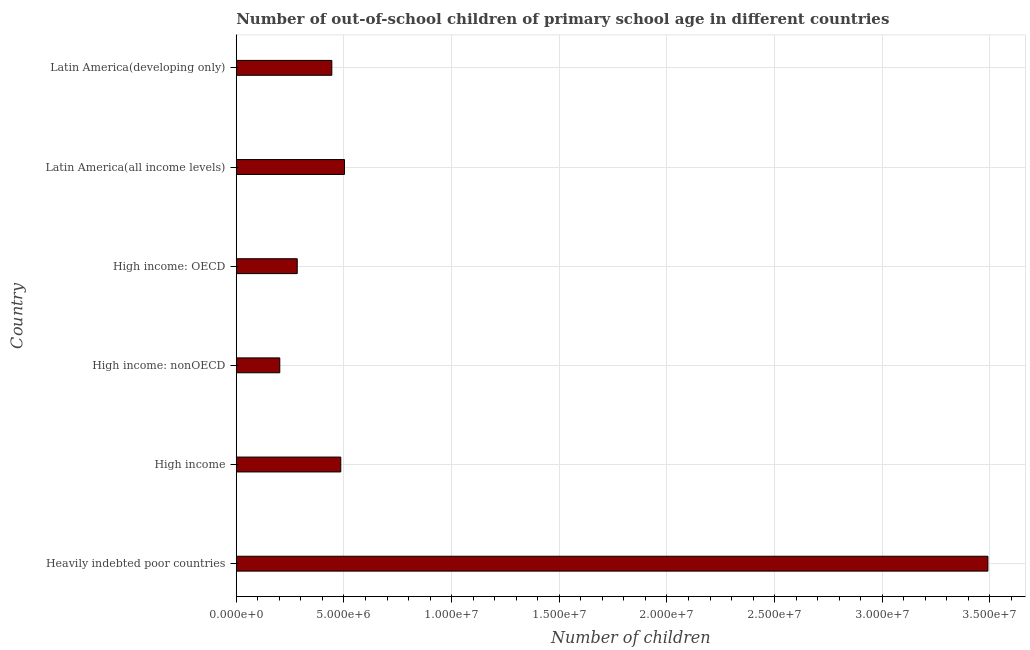Does the graph contain grids?
Provide a short and direct response. Yes. What is the title of the graph?
Offer a very short reply. Number of out-of-school children of primary school age in different countries. What is the label or title of the X-axis?
Offer a terse response. Number of children. What is the label or title of the Y-axis?
Your response must be concise. Country. What is the number of out-of-school children in Latin America(all income levels)?
Your answer should be very brief. 5.03e+06. Across all countries, what is the maximum number of out-of-school children?
Your answer should be very brief. 3.49e+07. Across all countries, what is the minimum number of out-of-school children?
Provide a succinct answer. 2.02e+06. In which country was the number of out-of-school children maximum?
Give a very brief answer. Heavily indebted poor countries. In which country was the number of out-of-school children minimum?
Give a very brief answer. High income: nonOECD. What is the sum of the number of out-of-school children?
Keep it short and to the point. 5.41e+07. What is the difference between the number of out-of-school children in Heavily indebted poor countries and High income: OECD?
Provide a succinct answer. 3.21e+07. What is the average number of out-of-school children per country?
Your answer should be compact. 9.01e+06. What is the median number of out-of-school children?
Provide a succinct answer. 4.65e+06. What is the ratio of the number of out-of-school children in Heavily indebted poor countries to that in Latin America(all income levels)?
Provide a short and direct response. 6.94. What is the difference between the highest and the second highest number of out-of-school children?
Ensure brevity in your answer.  2.99e+07. Is the sum of the number of out-of-school children in Heavily indebted poor countries and High income greater than the maximum number of out-of-school children across all countries?
Your response must be concise. Yes. What is the difference between the highest and the lowest number of out-of-school children?
Your answer should be compact. 3.29e+07. Are all the bars in the graph horizontal?
Make the answer very short. Yes. What is the difference between two consecutive major ticks on the X-axis?
Ensure brevity in your answer.  5.00e+06. What is the Number of children of Heavily indebted poor countries?
Offer a very short reply. 3.49e+07. What is the Number of children of High income?
Provide a succinct answer. 4.85e+06. What is the Number of children of High income: nonOECD?
Your answer should be very brief. 2.02e+06. What is the Number of children of High income: OECD?
Offer a very short reply. 2.83e+06. What is the Number of children in Latin America(all income levels)?
Keep it short and to the point. 5.03e+06. What is the Number of children in Latin America(developing only)?
Provide a succinct answer. 4.44e+06. What is the difference between the Number of children in Heavily indebted poor countries and High income?
Give a very brief answer. 3.01e+07. What is the difference between the Number of children in Heavily indebted poor countries and High income: nonOECD?
Keep it short and to the point. 3.29e+07. What is the difference between the Number of children in Heavily indebted poor countries and High income: OECD?
Your answer should be very brief. 3.21e+07. What is the difference between the Number of children in Heavily indebted poor countries and Latin America(all income levels)?
Your response must be concise. 2.99e+07. What is the difference between the Number of children in Heavily indebted poor countries and Latin America(developing only)?
Your response must be concise. 3.05e+07. What is the difference between the Number of children in High income and High income: nonOECD?
Your answer should be compact. 2.83e+06. What is the difference between the Number of children in High income and High income: OECD?
Keep it short and to the point. 2.02e+06. What is the difference between the Number of children in High income and Latin America(all income levels)?
Keep it short and to the point. -1.74e+05. What is the difference between the Number of children in High income and Latin America(developing only)?
Make the answer very short. 4.15e+05. What is the difference between the Number of children in High income: nonOECD and High income: OECD?
Your response must be concise. -8.10e+05. What is the difference between the Number of children in High income: nonOECD and Latin America(all income levels)?
Your answer should be compact. -3.01e+06. What is the difference between the Number of children in High income: nonOECD and Latin America(developing only)?
Provide a succinct answer. -2.42e+06. What is the difference between the Number of children in High income: OECD and Latin America(all income levels)?
Give a very brief answer. -2.20e+06. What is the difference between the Number of children in High income: OECD and Latin America(developing only)?
Keep it short and to the point. -1.61e+06. What is the difference between the Number of children in Latin America(all income levels) and Latin America(developing only)?
Ensure brevity in your answer.  5.88e+05. What is the ratio of the Number of children in Heavily indebted poor countries to that in High income?
Your response must be concise. 7.19. What is the ratio of the Number of children in Heavily indebted poor countries to that in High income: nonOECD?
Your answer should be very brief. 17.27. What is the ratio of the Number of children in Heavily indebted poor countries to that in High income: OECD?
Your answer should be compact. 12.33. What is the ratio of the Number of children in Heavily indebted poor countries to that in Latin America(all income levels)?
Provide a short and direct response. 6.94. What is the ratio of the Number of children in Heavily indebted poor countries to that in Latin America(developing only)?
Provide a short and direct response. 7.86. What is the ratio of the Number of children in High income to that in High income: nonOECD?
Make the answer very short. 2.4. What is the ratio of the Number of children in High income to that in High income: OECD?
Provide a succinct answer. 1.71. What is the ratio of the Number of children in High income to that in Latin America(all income levels)?
Offer a very short reply. 0.96. What is the ratio of the Number of children in High income to that in Latin America(developing only)?
Give a very brief answer. 1.09. What is the ratio of the Number of children in High income: nonOECD to that in High income: OECD?
Ensure brevity in your answer.  0.71. What is the ratio of the Number of children in High income: nonOECD to that in Latin America(all income levels)?
Your response must be concise. 0.4. What is the ratio of the Number of children in High income: nonOECD to that in Latin America(developing only)?
Give a very brief answer. 0.46. What is the ratio of the Number of children in High income: OECD to that in Latin America(all income levels)?
Offer a terse response. 0.56. What is the ratio of the Number of children in High income: OECD to that in Latin America(developing only)?
Make the answer very short. 0.64. What is the ratio of the Number of children in Latin America(all income levels) to that in Latin America(developing only)?
Ensure brevity in your answer.  1.13. 